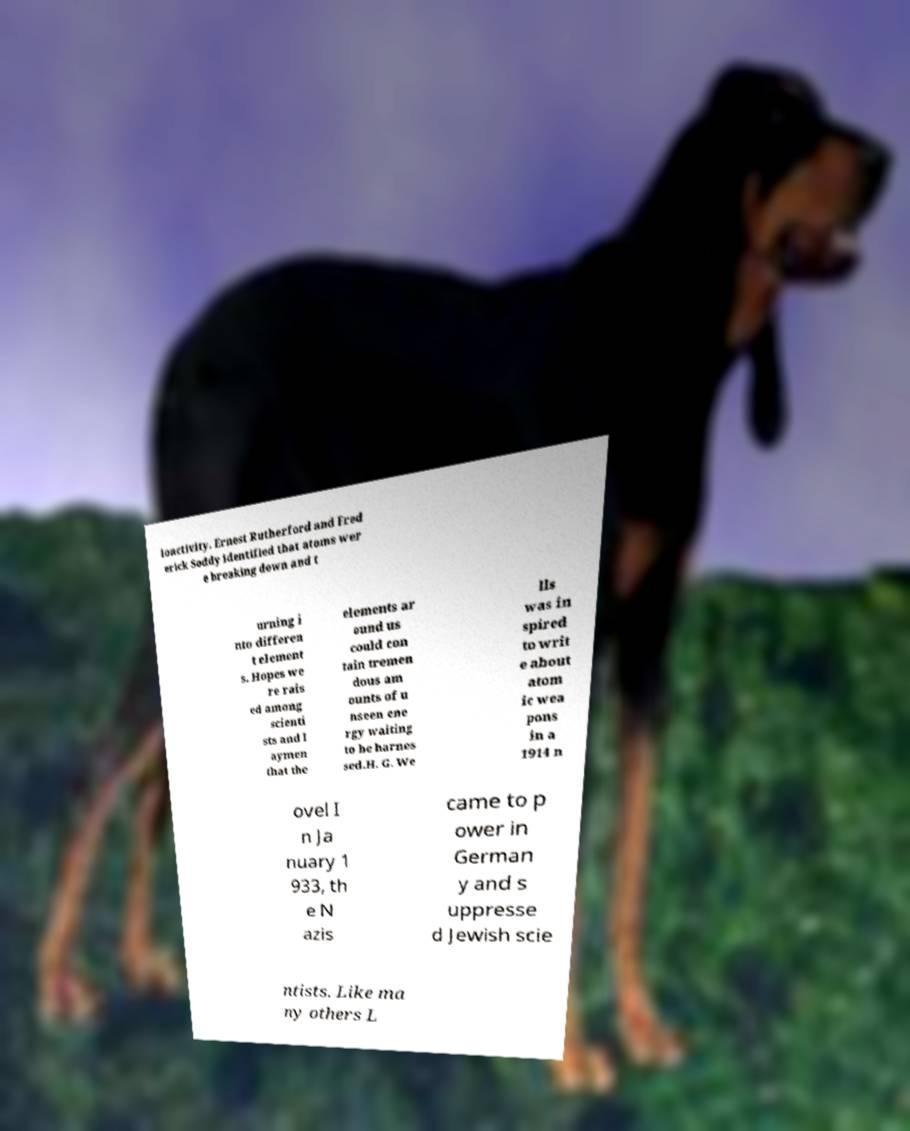What messages or text are displayed in this image? I need them in a readable, typed format. ioactivity. Ernest Rutherford and Fred erick Soddy identified that atoms wer e breaking down and t urning i nto differen t element s. Hopes we re rais ed among scienti sts and l aymen that the elements ar ound us could con tain tremen dous am ounts of u nseen ene rgy waiting to be harnes sed.H. G. We lls was in spired to writ e about atom ic wea pons in a 1914 n ovel I n Ja nuary 1 933, th e N azis came to p ower in German y and s uppresse d Jewish scie ntists. Like ma ny others L 